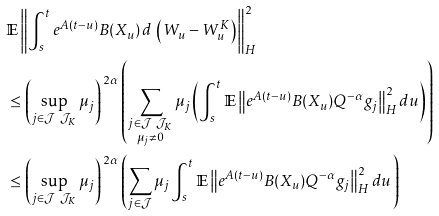Convert formula to latex. <formula><loc_0><loc_0><loc_500><loc_500>& \mathbb { E } \left \| \int _ { s } ^ { t } e ^ { A ( t - u ) } B ( X _ { u } ) \, d \, \left ( W _ { u } - W ^ { K } _ { u } \right ) \right \| _ { H } ^ { 2 } \\ & \leq \left ( \sup _ { j \in \mathcal { J } \ \mathcal { J } _ { K } } \mu _ { j } \right ) ^ { \, 2 \alpha } \left ( \sum _ { \substack { j \in \mathcal { J } \ \mathcal { J } _ { K } \\ \mu _ { j } \neq 0 } } \mu _ { j } \left ( \int _ { s } ^ { t } \mathbb { E } \left \| e ^ { A ( t - u ) } B ( X _ { u } ) Q ^ { - \alpha } g _ { j } \right \| _ { H } ^ { 2 } d u \right ) \right ) \\ & \leq \left ( \sup _ { j \in \mathcal { J } \ \mathcal { J } _ { K } } \mu _ { j } \right ) ^ { \, 2 \alpha } \left ( \sum _ { j \in \mathcal { J } } \mu _ { j } \int _ { s } ^ { t } \mathbb { E } \left \| e ^ { A ( t - u ) } B ( X _ { u } ) Q ^ { - \alpha } g _ { j } \right \| _ { H } ^ { 2 } d u \right )</formula> 